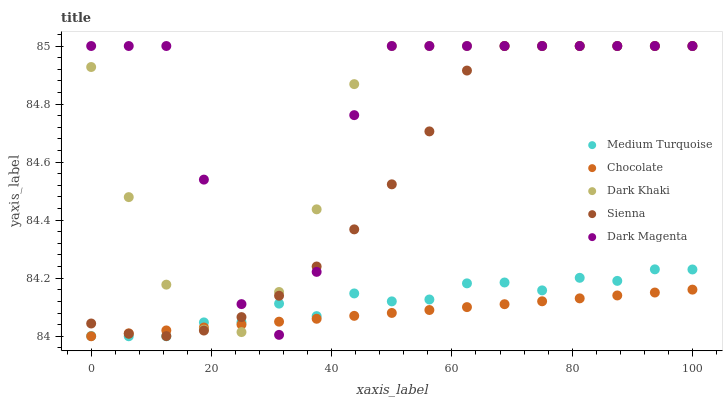Does Chocolate have the minimum area under the curve?
Answer yes or no. Yes. Does Dark Magenta have the maximum area under the curve?
Answer yes or no. Yes. Does Sienna have the minimum area under the curve?
Answer yes or no. No. Does Sienna have the maximum area under the curve?
Answer yes or no. No. Is Chocolate the smoothest?
Answer yes or no. Yes. Is Dark Magenta the roughest?
Answer yes or no. Yes. Is Sienna the smoothest?
Answer yes or no. No. Is Sienna the roughest?
Answer yes or no. No. Does Medium Turquoise have the lowest value?
Answer yes or no. Yes. Does Sienna have the lowest value?
Answer yes or no. No. Does Dark Magenta have the highest value?
Answer yes or no. Yes. Does Medium Turquoise have the highest value?
Answer yes or no. No. Does Dark Khaki intersect Medium Turquoise?
Answer yes or no. Yes. Is Dark Khaki less than Medium Turquoise?
Answer yes or no. No. Is Dark Khaki greater than Medium Turquoise?
Answer yes or no. No. 